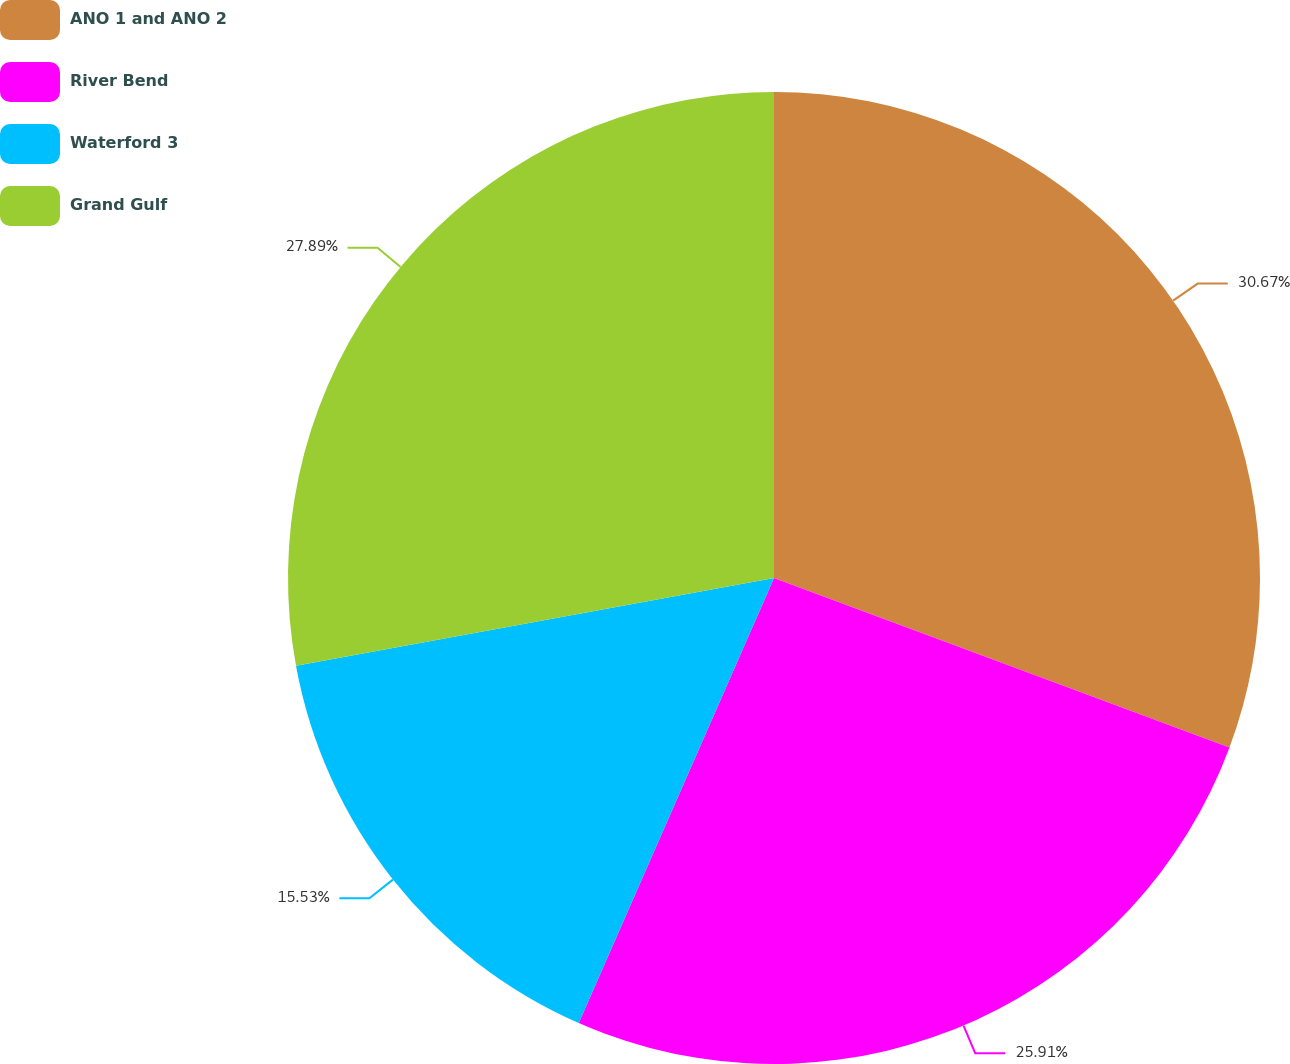<chart> <loc_0><loc_0><loc_500><loc_500><pie_chart><fcel>ANO 1 and ANO 2<fcel>River Bend<fcel>Waterford 3<fcel>Grand Gulf<nl><fcel>30.67%<fcel>25.91%<fcel>15.53%<fcel>27.89%<nl></chart> 